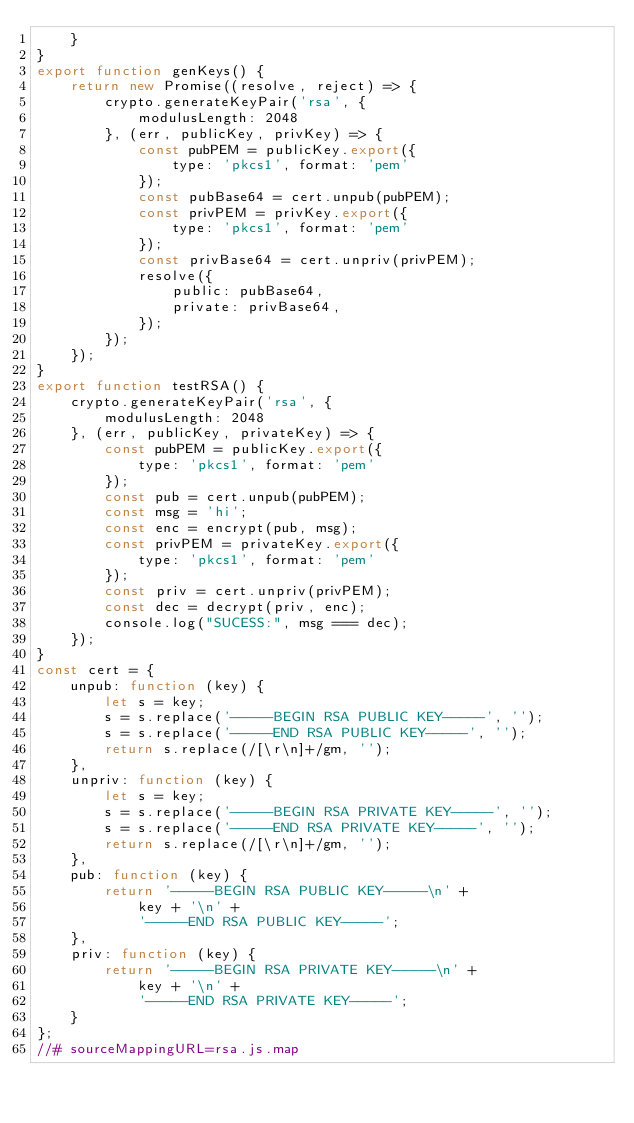Convert code to text. <code><loc_0><loc_0><loc_500><loc_500><_JavaScript_>    }
}
export function genKeys() {
    return new Promise((resolve, reject) => {
        crypto.generateKeyPair('rsa', {
            modulusLength: 2048
        }, (err, publicKey, privKey) => {
            const pubPEM = publicKey.export({
                type: 'pkcs1', format: 'pem'
            });
            const pubBase64 = cert.unpub(pubPEM);
            const privPEM = privKey.export({
                type: 'pkcs1', format: 'pem'
            });
            const privBase64 = cert.unpriv(privPEM);
            resolve({
                public: pubBase64,
                private: privBase64,
            });
        });
    });
}
export function testRSA() {
    crypto.generateKeyPair('rsa', {
        modulusLength: 2048
    }, (err, publicKey, privateKey) => {
        const pubPEM = publicKey.export({
            type: 'pkcs1', format: 'pem'
        });
        const pub = cert.unpub(pubPEM);
        const msg = 'hi';
        const enc = encrypt(pub, msg);
        const privPEM = privateKey.export({
            type: 'pkcs1', format: 'pem'
        });
        const priv = cert.unpriv(privPEM);
        const dec = decrypt(priv, enc);
        console.log("SUCESS:", msg === dec);
    });
}
const cert = {
    unpub: function (key) {
        let s = key;
        s = s.replace('-----BEGIN RSA PUBLIC KEY-----', '');
        s = s.replace('-----END RSA PUBLIC KEY-----', '');
        return s.replace(/[\r\n]+/gm, '');
    },
    unpriv: function (key) {
        let s = key;
        s = s.replace('-----BEGIN RSA PRIVATE KEY-----', '');
        s = s.replace('-----END RSA PRIVATE KEY-----', '');
        return s.replace(/[\r\n]+/gm, '');
    },
    pub: function (key) {
        return '-----BEGIN RSA PUBLIC KEY-----\n' +
            key + '\n' +
            '-----END RSA PUBLIC KEY-----';
    },
    priv: function (key) {
        return '-----BEGIN RSA PRIVATE KEY-----\n' +
            key + '\n' +
            '-----END RSA PRIVATE KEY-----';
    }
};
//# sourceMappingURL=rsa.js.map</code> 